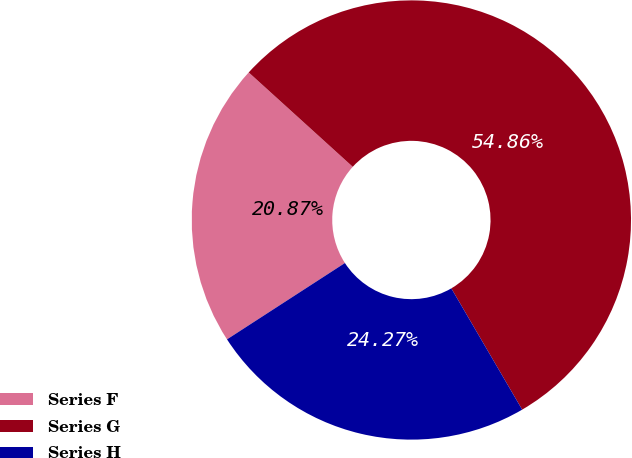Convert chart to OTSL. <chart><loc_0><loc_0><loc_500><loc_500><pie_chart><fcel>Series F<fcel>Series G<fcel>Series H<nl><fcel>20.87%<fcel>54.86%<fcel>24.27%<nl></chart> 